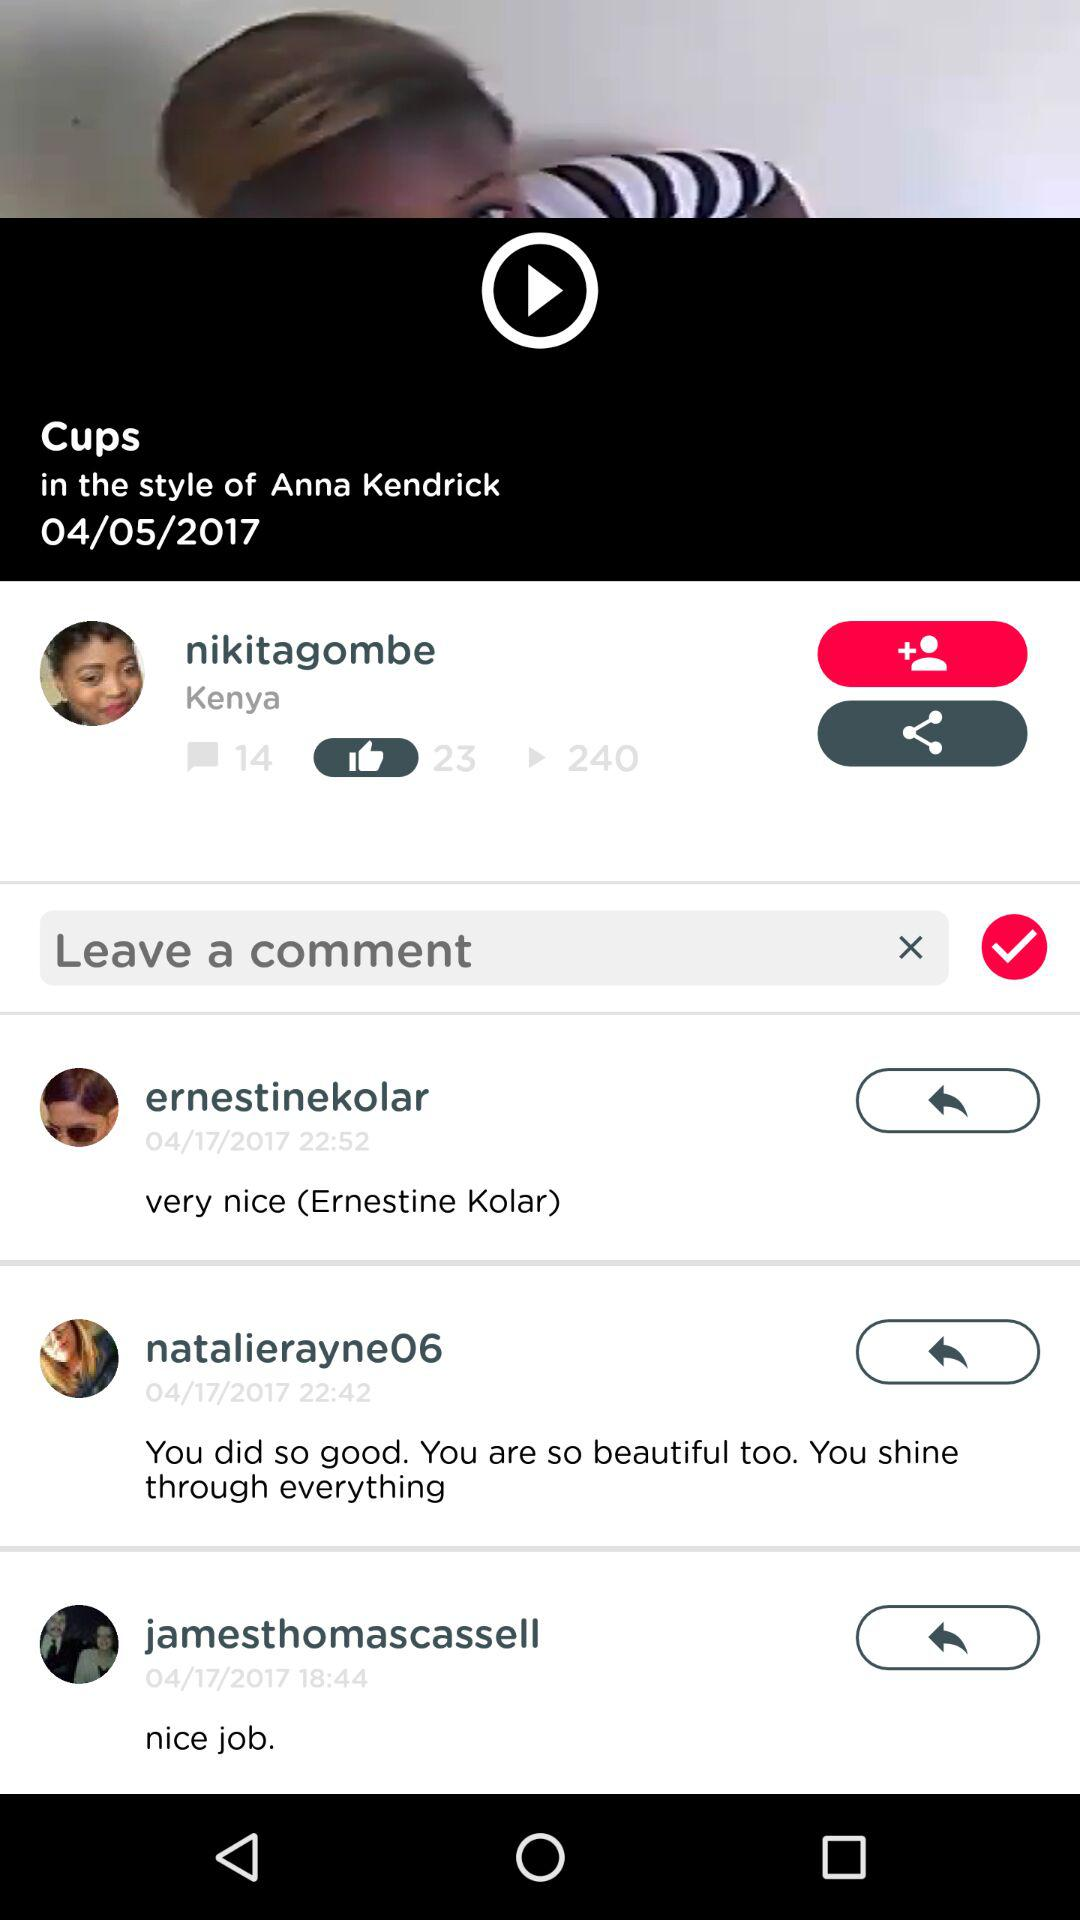How many plays in total are there on the video? There are 240 plays. 